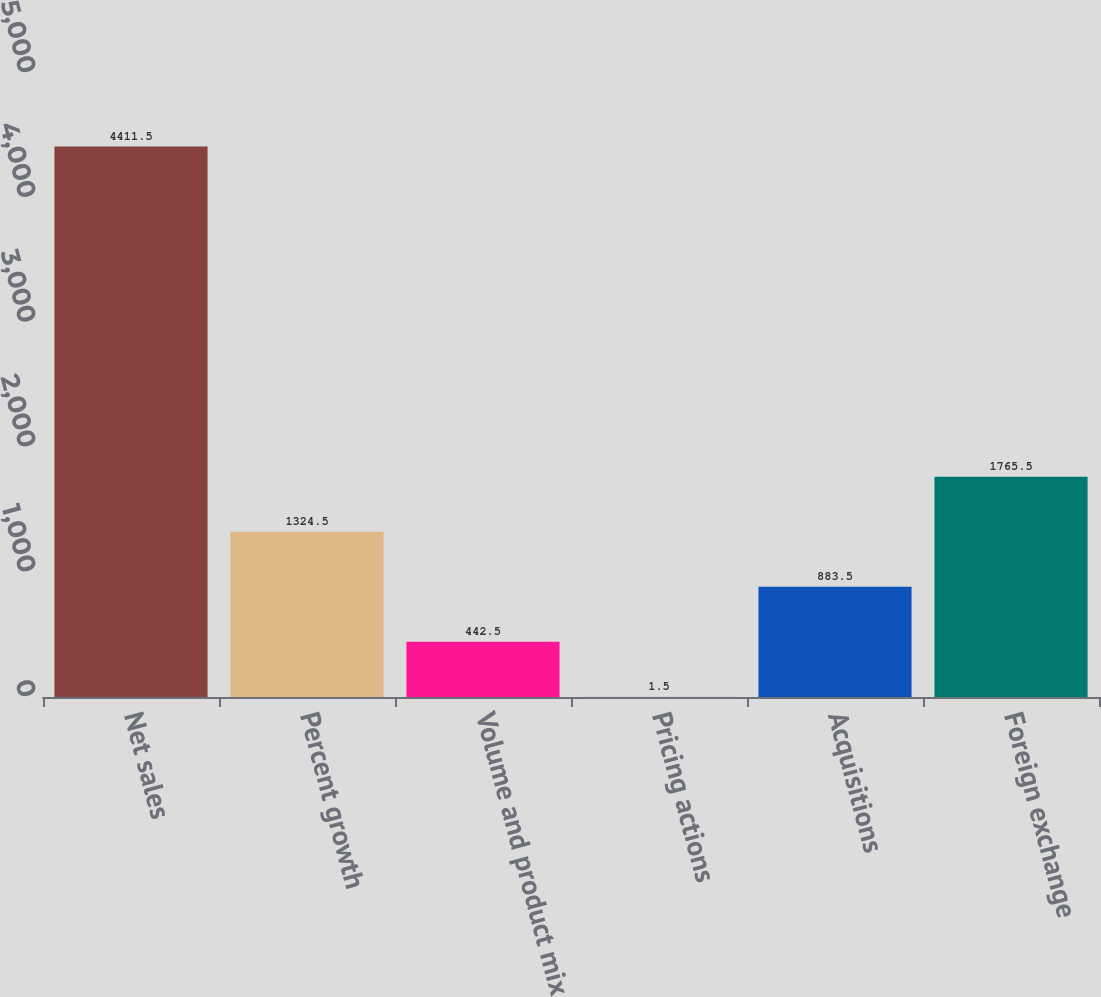Convert chart to OTSL. <chart><loc_0><loc_0><loc_500><loc_500><bar_chart><fcel>Net sales<fcel>Percent growth<fcel>Volume and product mix<fcel>Pricing actions<fcel>Acquisitions<fcel>Foreign exchange<nl><fcel>4411.5<fcel>1324.5<fcel>442.5<fcel>1.5<fcel>883.5<fcel>1765.5<nl></chart> 